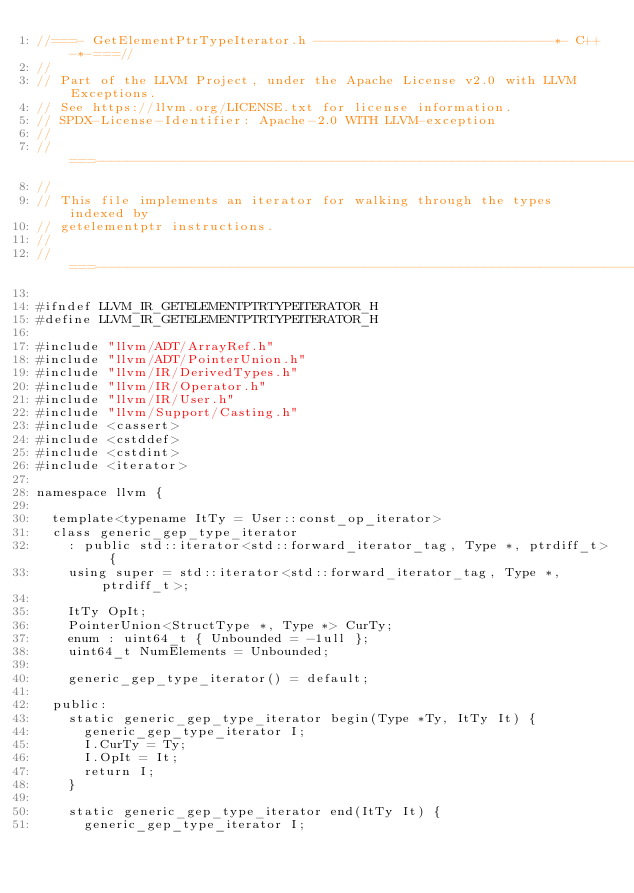Convert code to text. <code><loc_0><loc_0><loc_500><loc_500><_C_>//===- GetElementPtrTypeIterator.h ------------------------------*- C++ -*-===//
//
// Part of the LLVM Project, under the Apache License v2.0 with LLVM Exceptions.
// See https://llvm.org/LICENSE.txt for license information.
// SPDX-License-Identifier: Apache-2.0 WITH LLVM-exception
//
//===----------------------------------------------------------------------===//
//
// This file implements an iterator for walking through the types indexed by
// getelementptr instructions.
//
//===----------------------------------------------------------------------===//

#ifndef LLVM_IR_GETELEMENTPTRTYPEITERATOR_H
#define LLVM_IR_GETELEMENTPTRTYPEITERATOR_H

#include "llvm/ADT/ArrayRef.h"
#include "llvm/ADT/PointerUnion.h"
#include "llvm/IR/DerivedTypes.h"
#include "llvm/IR/Operator.h"
#include "llvm/IR/User.h"
#include "llvm/Support/Casting.h"
#include <cassert>
#include <cstddef>
#include <cstdint>
#include <iterator>

namespace llvm {

  template<typename ItTy = User::const_op_iterator>
  class generic_gep_type_iterator
    : public std::iterator<std::forward_iterator_tag, Type *, ptrdiff_t> {
    using super = std::iterator<std::forward_iterator_tag, Type *, ptrdiff_t>;

    ItTy OpIt;
    PointerUnion<StructType *, Type *> CurTy;
    enum : uint64_t { Unbounded = -1ull };
    uint64_t NumElements = Unbounded;

    generic_gep_type_iterator() = default;

  public:
    static generic_gep_type_iterator begin(Type *Ty, ItTy It) {
      generic_gep_type_iterator I;
      I.CurTy = Ty;
      I.OpIt = It;
      return I;
    }

    static generic_gep_type_iterator end(ItTy It) {
      generic_gep_type_iterator I;</code> 